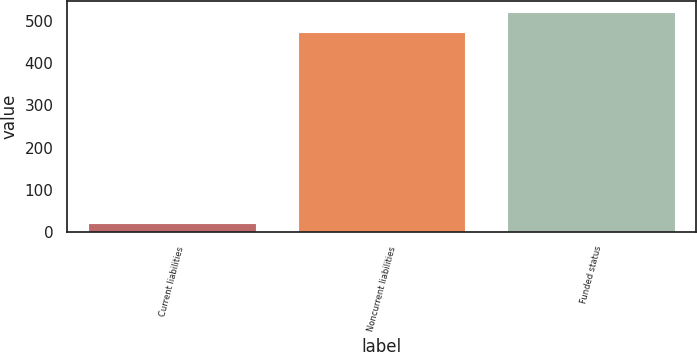Convert chart. <chart><loc_0><loc_0><loc_500><loc_500><bar_chart><fcel>Current liabilities<fcel>Noncurrent liabilities<fcel>Funded status<nl><fcel>20<fcel>474<fcel>521.4<nl></chart> 